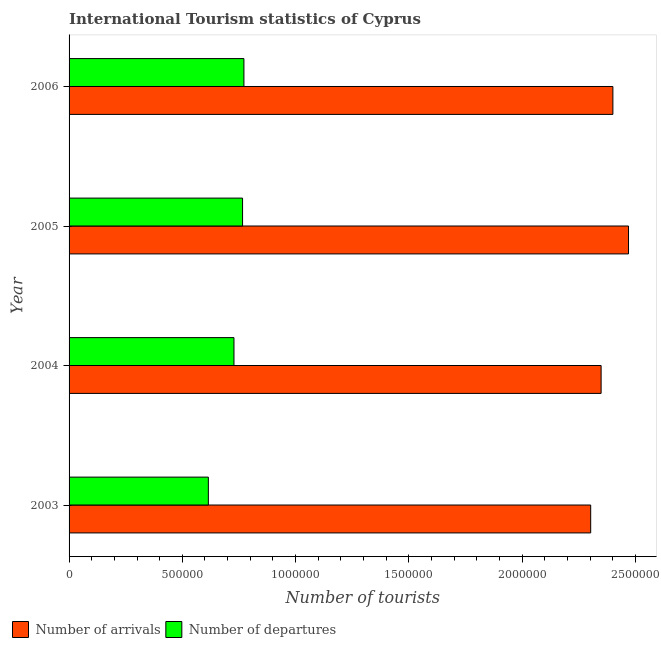How many groups of bars are there?
Your response must be concise. 4. Are the number of bars per tick equal to the number of legend labels?
Offer a very short reply. Yes. How many bars are there on the 3rd tick from the top?
Your answer should be very brief. 2. In how many cases, is the number of bars for a given year not equal to the number of legend labels?
Keep it short and to the point. 0. What is the number of tourist arrivals in 2003?
Provide a succinct answer. 2.30e+06. Across all years, what is the maximum number of tourist arrivals?
Make the answer very short. 2.47e+06. Across all years, what is the minimum number of tourist departures?
Give a very brief answer. 6.15e+05. In which year was the number of tourist departures maximum?
Provide a short and direct response. 2006. What is the total number of tourist departures in the graph?
Give a very brief answer. 2.88e+06. What is the difference between the number of tourist departures in 2005 and that in 2006?
Offer a very short reply. -6000. What is the difference between the number of tourist departures in 2004 and the number of tourist arrivals in 2003?
Make the answer very short. -1.58e+06. What is the average number of tourist arrivals per year?
Give a very brief answer. 2.38e+06. In the year 2005, what is the difference between the number of tourist arrivals and number of tourist departures?
Ensure brevity in your answer.  1.70e+06. What is the ratio of the number of tourist arrivals in 2005 to that in 2006?
Make the answer very short. 1.03. Is the number of tourist arrivals in 2003 less than that in 2006?
Provide a short and direct response. Yes. What is the difference between the highest and the second highest number of tourist departures?
Your answer should be very brief. 6000. What is the difference between the highest and the lowest number of tourist departures?
Your answer should be compact. 1.57e+05. Is the sum of the number of tourist departures in 2004 and 2005 greater than the maximum number of tourist arrivals across all years?
Make the answer very short. No. What does the 1st bar from the top in 2003 represents?
Ensure brevity in your answer.  Number of departures. What does the 1st bar from the bottom in 2006 represents?
Offer a very short reply. Number of arrivals. How many bars are there?
Your answer should be very brief. 8. How many years are there in the graph?
Make the answer very short. 4. What is the difference between two consecutive major ticks on the X-axis?
Provide a succinct answer. 5.00e+05. Are the values on the major ticks of X-axis written in scientific E-notation?
Offer a very short reply. No. Does the graph contain any zero values?
Your answer should be compact. No. Does the graph contain grids?
Make the answer very short. No. Where does the legend appear in the graph?
Your response must be concise. Bottom left. How many legend labels are there?
Ensure brevity in your answer.  2. How are the legend labels stacked?
Offer a very short reply. Horizontal. What is the title of the graph?
Your answer should be very brief. International Tourism statistics of Cyprus. Does "2012 US$" appear as one of the legend labels in the graph?
Your answer should be very brief. No. What is the label or title of the X-axis?
Make the answer very short. Number of tourists. What is the label or title of the Y-axis?
Your answer should be very brief. Year. What is the Number of tourists in Number of arrivals in 2003?
Provide a succinct answer. 2.30e+06. What is the Number of tourists of Number of departures in 2003?
Provide a short and direct response. 6.15e+05. What is the Number of tourists in Number of arrivals in 2004?
Give a very brief answer. 2.35e+06. What is the Number of tourists of Number of departures in 2004?
Provide a succinct answer. 7.28e+05. What is the Number of tourists of Number of arrivals in 2005?
Your answer should be very brief. 2.47e+06. What is the Number of tourists of Number of departures in 2005?
Your response must be concise. 7.66e+05. What is the Number of tourists in Number of arrivals in 2006?
Provide a succinct answer. 2.40e+06. What is the Number of tourists of Number of departures in 2006?
Your answer should be very brief. 7.72e+05. Across all years, what is the maximum Number of tourists of Number of arrivals?
Make the answer very short. 2.47e+06. Across all years, what is the maximum Number of tourists of Number of departures?
Keep it short and to the point. 7.72e+05. Across all years, what is the minimum Number of tourists of Number of arrivals?
Provide a short and direct response. 2.30e+06. Across all years, what is the minimum Number of tourists in Number of departures?
Your response must be concise. 6.15e+05. What is the total Number of tourists of Number of arrivals in the graph?
Your answer should be compact. 9.52e+06. What is the total Number of tourists of Number of departures in the graph?
Your answer should be very brief. 2.88e+06. What is the difference between the Number of tourists of Number of arrivals in 2003 and that in 2004?
Your answer should be very brief. -4.60e+04. What is the difference between the Number of tourists in Number of departures in 2003 and that in 2004?
Your answer should be very brief. -1.13e+05. What is the difference between the Number of tourists of Number of arrivals in 2003 and that in 2005?
Ensure brevity in your answer.  -1.67e+05. What is the difference between the Number of tourists of Number of departures in 2003 and that in 2005?
Your response must be concise. -1.51e+05. What is the difference between the Number of tourists of Number of arrivals in 2003 and that in 2006?
Offer a very short reply. -9.80e+04. What is the difference between the Number of tourists in Number of departures in 2003 and that in 2006?
Your answer should be compact. -1.57e+05. What is the difference between the Number of tourists in Number of arrivals in 2004 and that in 2005?
Your answer should be compact. -1.21e+05. What is the difference between the Number of tourists of Number of departures in 2004 and that in 2005?
Your answer should be compact. -3.80e+04. What is the difference between the Number of tourists in Number of arrivals in 2004 and that in 2006?
Your answer should be compact. -5.20e+04. What is the difference between the Number of tourists in Number of departures in 2004 and that in 2006?
Your answer should be compact. -4.40e+04. What is the difference between the Number of tourists of Number of arrivals in 2005 and that in 2006?
Make the answer very short. 6.90e+04. What is the difference between the Number of tourists of Number of departures in 2005 and that in 2006?
Ensure brevity in your answer.  -6000. What is the difference between the Number of tourists of Number of arrivals in 2003 and the Number of tourists of Number of departures in 2004?
Offer a very short reply. 1.58e+06. What is the difference between the Number of tourists in Number of arrivals in 2003 and the Number of tourists in Number of departures in 2005?
Your response must be concise. 1.54e+06. What is the difference between the Number of tourists of Number of arrivals in 2003 and the Number of tourists of Number of departures in 2006?
Offer a very short reply. 1.53e+06. What is the difference between the Number of tourists in Number of arrivals in 2004 and the Number of tourists in Number of departures in 2005?
Your answer should be compact. 1.58e+06. What is the difference between the Number of tourists of Number of arrivals in 2004 and the Number of tourists of Number of departures in 2006?
Your answer should be compact. 1.58e+06. What is the difference between the Number of tourists of Number of arrivals in 2005 and the Number of tourists of Number of departures in 2006?
Provide a succinct answer. 1.70e+06. What is the average Number of tourists of Number of arrivals per year?
Provide a succinct answer. 2.38e+06. What is the average Number of tourists in Number of departures per year?
Give a very brief answer. 7.20e+05. In the year 2003, what is the difference between the Number of tourists of Number of arrivals and Number of tourists of Number of departures?
Your answer should be compact. 1.69e+06. In the year 2004, what is the difference between the Number of tourists in Number of arrivals and Number of tourists in Number of departures?
Offer a terse response. 1.62e+06. In the year 2005, what is the difference between the Number of tourists in Number of arrivals and Number of tourists in Number of departures?
Offer a very short reply. 1.70e+06. In the year 2006, what is the difference between the Number of tourists of Number of arrivals and Number of tourists of Number of departures?
Give a very brief answer. 1.63e+06. What is the ratio of the Number of tourists of Number of arrivals in 2003 to that in 2004?
Keep it short and to the point. 0.98. What is the ratio of the Number of tourists of Number of departures in 2003 to that in 2004?
Offer a very short reply. 0.84. What is the ratio of the Number of tourists in Number of arrivals in 2003 to that in 2005?
Your response must be concise. 0.93. What is the ratio of the Number of tourists in Number of departures in 2003 to that in 2005?
Provide a short and direct response. 0.8. What is the ratio of the Number of tourists of Number of arrivals in 2003 to that in 2006?
Ensure brevity in your answer.  0.96. What is the ratio of the Number of tourists in Number of departures in 2003 to that in 2006?
Provide a short and direct response. 0.8. What is the ratio of the Number of tourists in Number of arrivals in 2004 to that in 2005?
Ensure brevity in your answer.  0.95. What is the ratio of the Number of tourists of Number of departures in 2004 to that in 2005?
Provide a succinct answer. 0.95. What is the ratio of the Number of tourists in Number of arrivals in 2004 to that in 2006?
Give a very brief answer. 0.98. What is the ratio of the Number of tourists of Number of departures in 2004 to that in 2006?
Ensure brevity in your answer.  0.94. What is the ratio of the Number of tourists of Number of arrivals in 2005 to that in 2006?
Your response must be concise. 1.03. What is the difference between the highest and the second highest Number of tourists in Number of arrivals?
Your answer should be very brief. 6.90e+04. What is the difference between the highest and the second highest Number of tourists in Number of departures?
Ensure brevity in your answer.  6000. What is the difference between the highest and the lowest Number of tourists of Number of arrivals?
Give a very brief answer. 1.67e+05. What is the difference between the highest and the lowest Number of tourists in Number of departures?
Keep it short and to the point. 1.57e+05. 